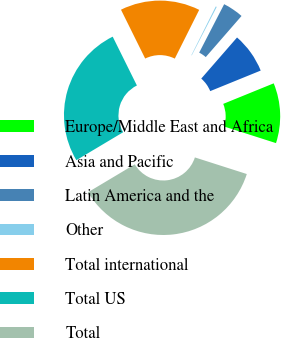Convert chart to OTSL. <chart><loc_0><loc_0><loc_500><loc_500><pie_chart><fcel>Europe/Middle East and Africa<fcel>Asia and Pacific<fcel>Latin America and the<fcel>Other<fcel>Total international<fcel>Total US<fcel>Total<nl><fcel>11.08%<fcel>7.45%<fcel>3.82%<fcel>0.19%<fcel>14.71%<fcel>26.24%<fcel>36.5%<nl></chart> 